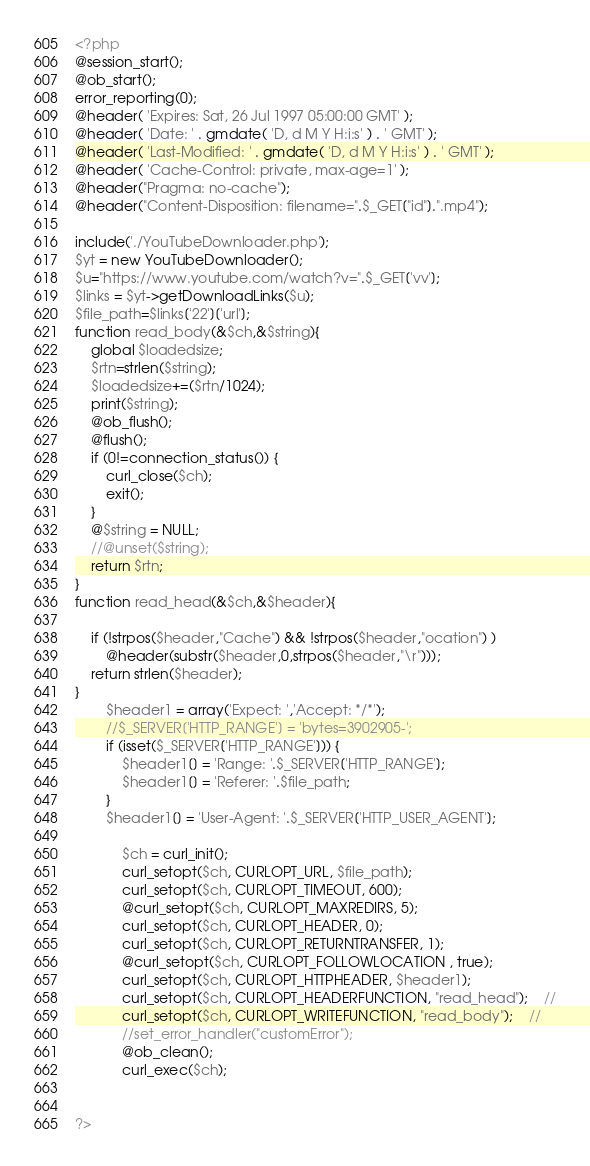Convert code to text. <code><loc_0><loc_0><loc_500><loc_500><_PHP_><?php
@session_start();
@ob_start();
error_reporting(0);
@header( 'Expires: Sat, 26 Jul 1997 05:00:00 GMT' ); 
@header( 'Date: ' . gmdate( 'D, d M Y H:i:s' ) . ' GMT' ); 
@header( 'Last-Modified: ' . gmdate( 'D, d M Y H:i:s' ) . ' GMT' ); 
@header( 'Cache-Control: private, max-age=1' ); 
@header("Pragma: no-cache");
@header("Content-Disposition: filename=".$_GET["id"].".mp4");

include('./YouTubeDownloader.php');
$yt = new YouTubeDownloader();
$u="https://www.youtube.com/watch?v=".$_GET['vv'];
$links = $yt->getDownloadLinks($u);
$file_path=$links['22']['url'];
function read_body(&$ch,&$string){
	global $loadedsize;
	$rtn=strlen($string);
	$loadedsize+=($rtn/1024);
	print($string);
	@ob_flush();
	@flush();
	if (0!=connection_status()) {
		curl_close($ch);
		exit();
	}
	@$string = NULL;
	//@unset($string);
	return $rtn;
}
function read_head(&$ch,&$header){
	
	if (!strpos($header,"Cache") && !strpos($header,"ocation") )
		@header(substr($header,0,strpos($header,"\r")));
    return strlen($header); 
}
		$header1 = array('Expect: ','Accept: */*');
		//$_SERVER['HTTP_RANGE'] = 'bytes=3902905-';
		if (isset($_SERVER['HTTP_RANGE'])) {
			$header1[] = 'Range: '.$_SERVER['HTTP_RANGE'];
			$header1[] = 'Referer: '.$file_path;
		}
		$header1[] = 'User-Agent: '.$_SERVER['HTTP_USER_AGENT'];
		
			$ch = curl_init();
			curl_setopt($ch, CURLOPT_URL, $file_path);
			curl_setopt($ch, CURLOPT_TIMEOUT, 600);
			@curl_setopt($ch, CURLOPT_MAXREDIRS, 5);
			curl_setopt($ch, CURLOPT_HEADER, 0);
			curl_setopt($ch, CURLOPT_RETURNTRANSFER, 1);
			@curl_setopt($ch, CURLOPT_FOLLOWLOCATION , true);
        	curl_setopt($ch, CURLOPT_HTTPHEADER, $header1);
			curl_setopt($ch, CURLOPT_HEADERFUNCTION, "read_head");	//
			curl_setopt($ch, CURLOPT_WRITEFUNCTION, "read_body");	//
			//set_error_handler("customError");
			@ob_clean();
			curl_exec($ch);
	

?></code> 